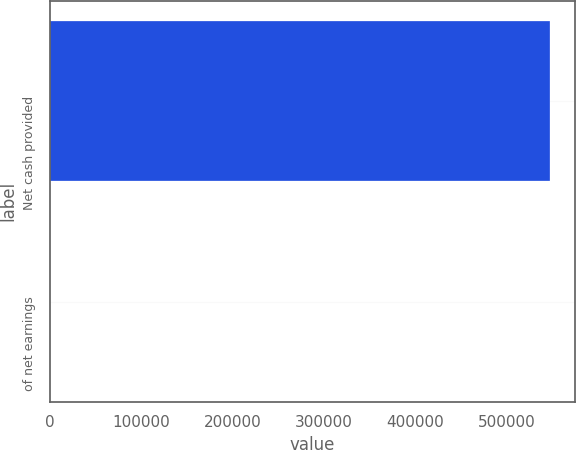Convert chart. <chart><loc_0><loc_0><loc_500><loc_500><bar_chart><fcel>Net cash provided<fcel>of net earnings<nl><fcel>546940<fcel>105.9<nl></chart> 